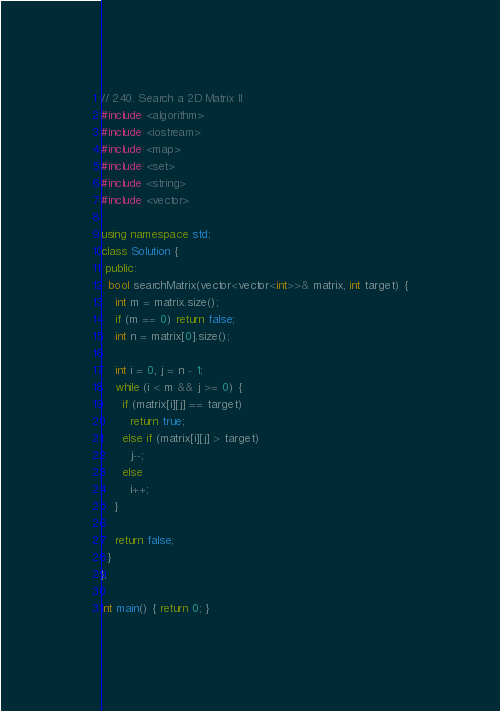<code> <loc_0><loc_0><loc_500><loc_500><_C++_>// 240. Search a 2D Matrix II
#include <algorithm>
#include <iostream>
#include <map>
#include <set>
#include <string>
#include <vector>

using namespace std;
class Solution {
 public:
  bool searchMatrix(vector<vector<int>>& matrix, int target) {
    int m = matrix.size();
    if (m == 0) return false;
    int n = matrix[0].size();

    int i = 0, j = n - 1;
    while (i < m && j >= 0) {
      if (matrix[i][j] == target)
        return true;
      else if (matrix[i][j] > target)
        j--;
      else
        i++;
    }

    return false;
  }
};

int main() { return 0; }</code> 